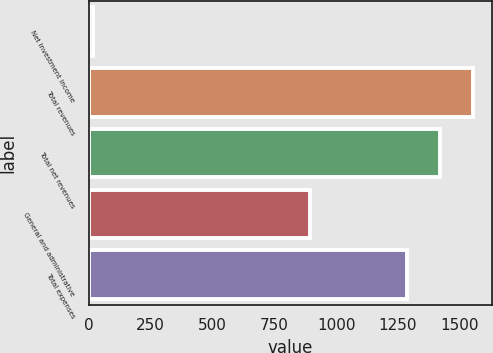<chart> <loc_0><loc_0><loc_500><loc_500><bar_chart><fcel>Net investment income<fcel>Total revenues<fcel>Total net revenues<fcel>General and administrative<fcel>Total expenses<nl><fcel>18<fcel>1552<fcel>1419<fcel>894<fcel>1286<nl></chart> 